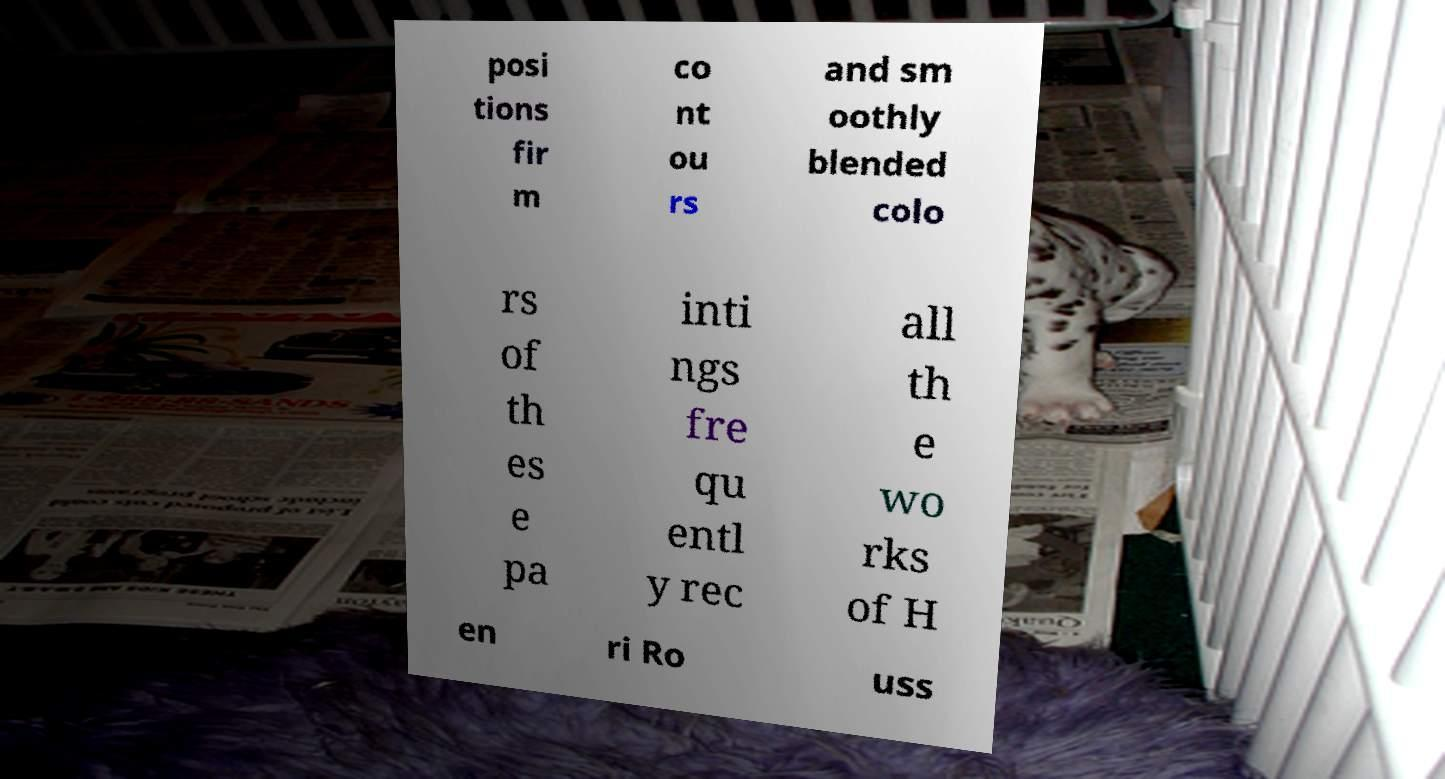There's text embedded in this image that I need extracted. Can you transcribe it verbatim? posi tions fir m co nt ou rs and sm oothly blended colo rs of th es e pa inti ngs fre qu entl y rec all th e wo rks of H en ri Ro uss 